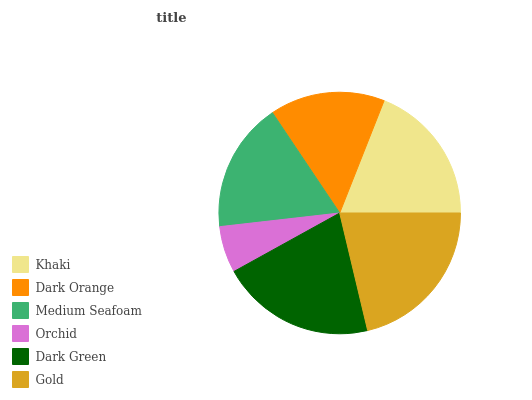Is Orchid the minimum?
Answer yes or no. Yes. Is Gold the maximum?
Answer yes or no. Yes. Is Dark Orange the minimum?
Answer yes or no. No. Is Dark Orange the maximum?
Answer yes or no. No. Is Khaki greater than Dark Orange?
Answer yes or no. Yes. Is Dark Orange less than Khaki?
Answer yes or no. Yes. Is Dark Orange greater than Khaki?
Answer yes or no. No. Is Khaki less than Dark Orange?
Answer yes or no. No. Is Khaki the high median?
Answer yes or no. Yes. Is Medium Seafoam the low median?
Answer yes or no. Yes. Is Dark Green the high median?
Answer yes or no. No. Is Dark Green the low median?
Answer yes or no. No. 